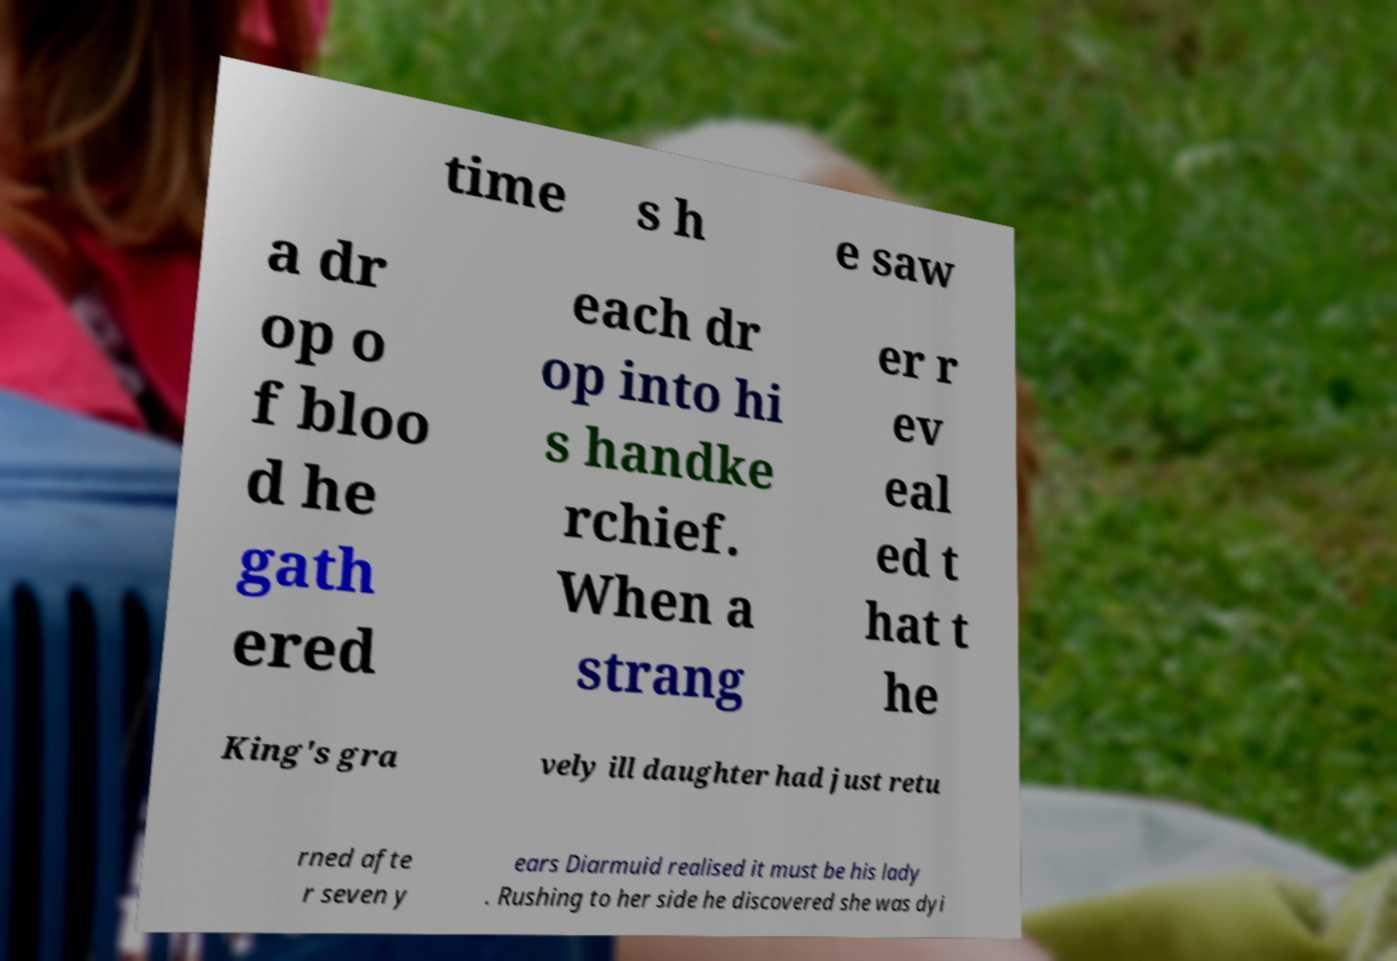I need the written content from this picture converted into text. Can you do that? time s h e saw a dr op o f bloo d he gath ered each dr op into hi s handke rchief. When a strang er r ev eal ed t hat t he King's gra vely ill daughter had just retu rned afte r seven y ears Diarmuid realised it must be his lady . Rushing to her side he discovered she was dyi 